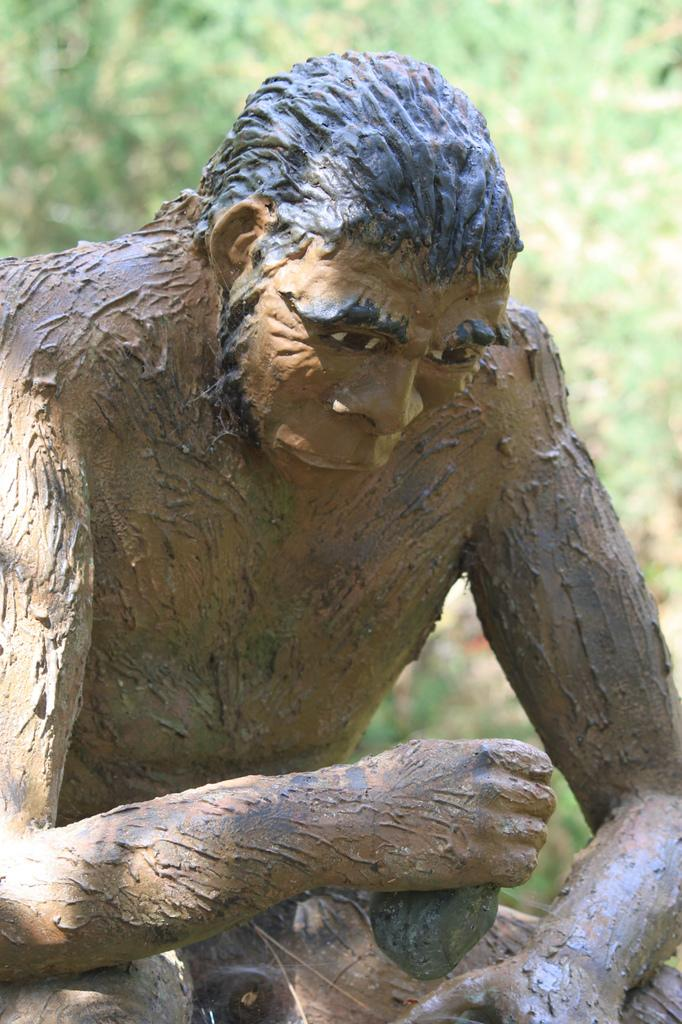What is the main subject of the image? There is a statue of an ape man in the image. How is the background of the image depicted? The background of the image is slightly blurred. What type of natural environment can be seen in the image? There are trees visible in the background of the image. What type of system is the ape man using to communicate with his grandfather in the image? There is no system or grandfather present in the image; it only features a statue of an ape man. What type of home is visible in the image? There is no home visible in the image; it only features a statue of an ape man and trees in the background. 